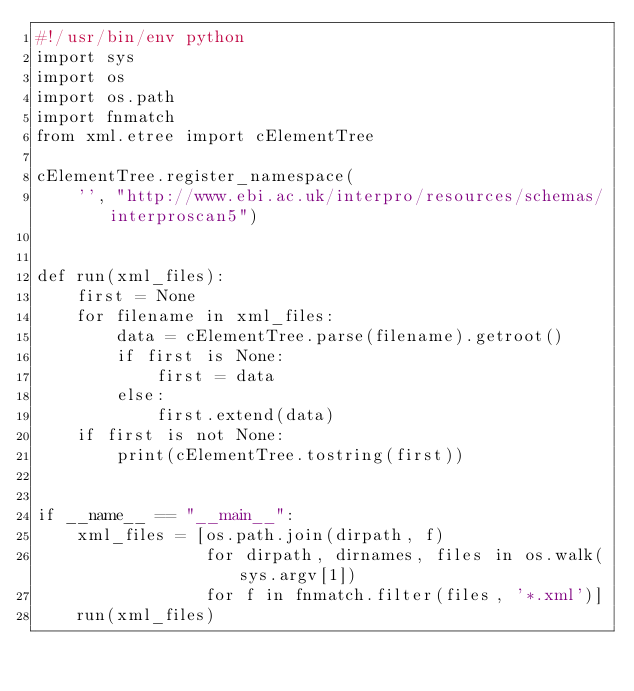Convert code to text. <code><loc_0><loc_0><loc_500><loc_500><_Python_>#!/usr/bin/env python
import sys
import os
import os.path
import fnmatch
from xml.etree import cElementTree

cElementTree.register_namespace(
    '', "http://www.ebi.ac.uk/interpro/resources/schemas/interproscan5")


def run(xml_files):
    first = None
    for filename in xml_files:
        data = cElementTree.parse(filename).getroot()
        if first is None:
            first = data
        else:
            first.extend(data)
    if first is not None:
        print(cElementTree.tostring(first))


if __name__ == "__main__":
    xml_files = [os.path.join(dirpath, f)
                 for dirpath, dirnames, files in os.walk(sys.argv[1])
                 for f in fnmatch.filter(files, '*.xml')]
    run(xml_files)
</code> 